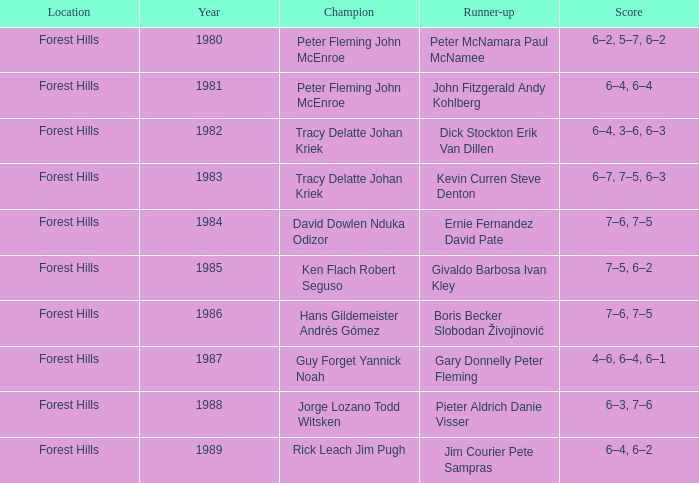Who was the runner-up in 1989? Jim Courier Pete Sampras. 